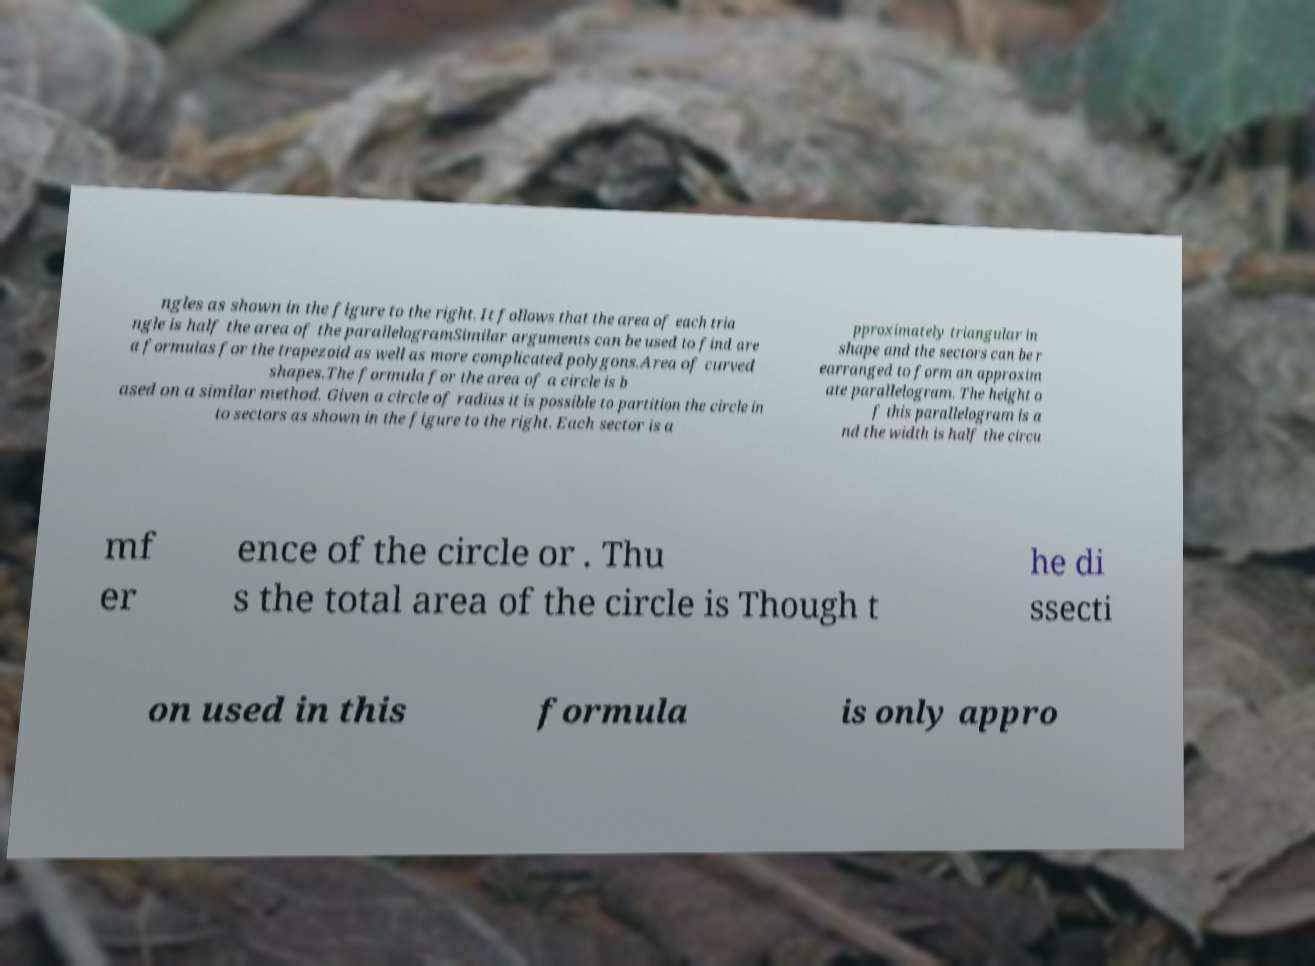Could you assist in decoding the text presented in this image and type it out clearly? ngles as shown in the figure to the right. It follows that the area of each tria ngle is half the area of the parallelogramSimilar arguments can be used to find are a formulas for the trapezoid as well as more complicated polygons.Area of curved shapes.The formula for the area of a circle is b ased on a similar method. Given a circle of radius it is possible to partition the circle in to sectors as shown in the figure to the right. Each sector is a pproximately triangular in shape and the sectors can be r earranged to form an approxim ate parallelogram. The height o f this parallelogram is a nd the width is half the circu mf er ence of the circle or . Thu s the total area of the circle is Though t he di ssecti on used in this formula is only appro 